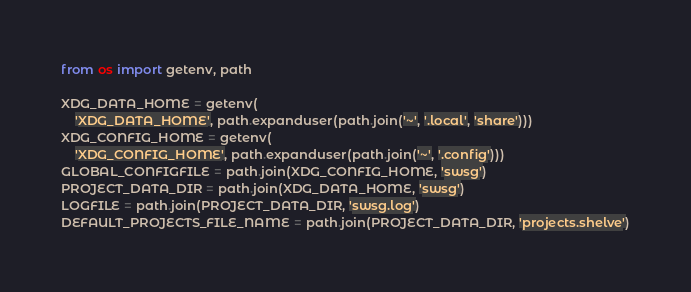<code> <loc_0><loc_0><loc_500><loc_500><_Python_>from os import getenv, path

XDG_DATA_HOME = getenv(
    'XDG_DATA_HOME', path.expanduser(path.join('~', '.local', 'share')))
XDG_CONFIG_HOME = getenv(
    'XDG_CONFIG_HOME', path.expanduser(path.join('~', '.config')))
GLOBAL_CONFIGFILE = path.join(XDG_CONFIG_HOME, 'swsg')
PROJECT_DATA_DIR = path.join(XDG_DATA_HOME, 'swsg')
LOGFILE = path.join(PROJECT_DATA_DIR, 'swsg.log')
DEFAULT_PROJECTS_FILE_NAME = path.join(PROJECT_DATA_DIR, 'projects.shelve')
</code> 